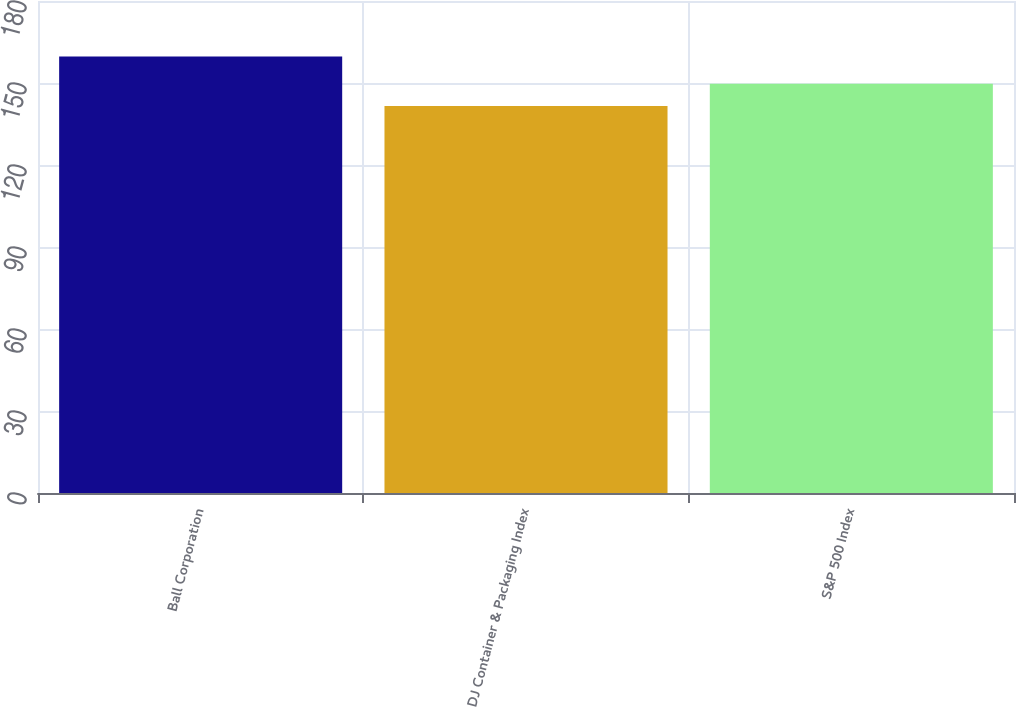Convert chart to OTSL. <chart><loc_0><loc_0><loc_500><loc_500><bar_chart><fcel>Ball Corporation<fcel>DJ Container & Packaging Index<fcel>S&P 500 Index<nl><fcel>159.71<fcel>141.56<fcel>149.7<nl></chart> 